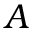<formula> <loc_0><loc_0><loc_500><loc_500>A</formula> 